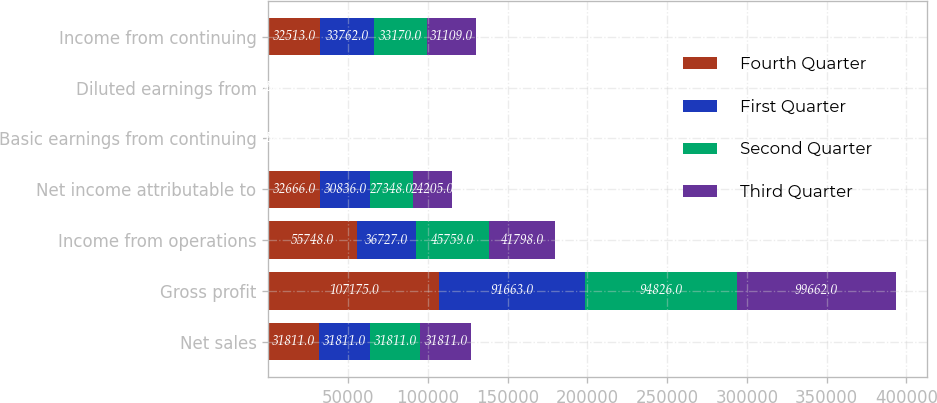<chart> <loc_0><loc_0><loc_500><loc_500><stacked_bar_chart><ecel><fcel>Net sales<fcel>Gross profit<fcel>Income from operations<fcel>Net income attributable to<fcel>Basic earnings from continuing<fcel>Diluted earnings from<fcel>Income from continuing<nl><fcel>Fourth Quarter<fcel>31811<fcel>107175<fcel>55748<fcel>32666<fcel>0.68<fcel>0.68<fcel>32513<nl><fcel>First Quarter<fcel>31811<fcel>91663<fcel>36727<fcel>30836<fcel>0.65<fcel>0.64<fcel>33762<nl><fcel>Second Quarter<fcel>31811<fcel>94826<fcel>45759<fcel>27348<fcel>0.58<fcel>0.57<fcel>33170<nl><fcel>Third Quarter<fcel>31811<fcel>99662<fcel>41798<fcel>24205<fcel>0.51<fcel>0.5<fcel>31109<nl></chart> 